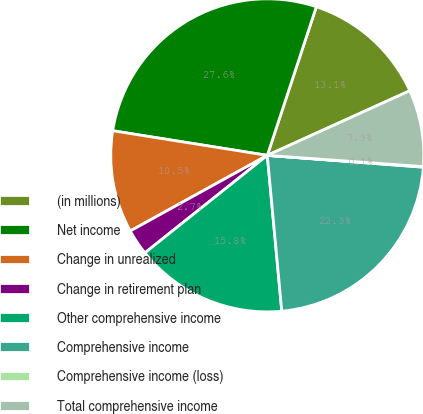Convert chart. <chart><loc_0><loc_0><loc_500><loc_500><pie_chart><fcel>(in millions)<fcel>Net income<fcel>Change in unrealized<fcel>Change in retirement plan<fcel>Other comprehensive income<fcel>Comprehensive income<fcel>Comprehensive income (loss)<fcel>Total comprehensive income<nl><fcel>13.15%<fcel>27.56%<fcel>10.54%<fcel>2.68%<fcel>15.77%<fcel>22.32%<fcel>0.06%<fcel>7.92%<nl></chart> 